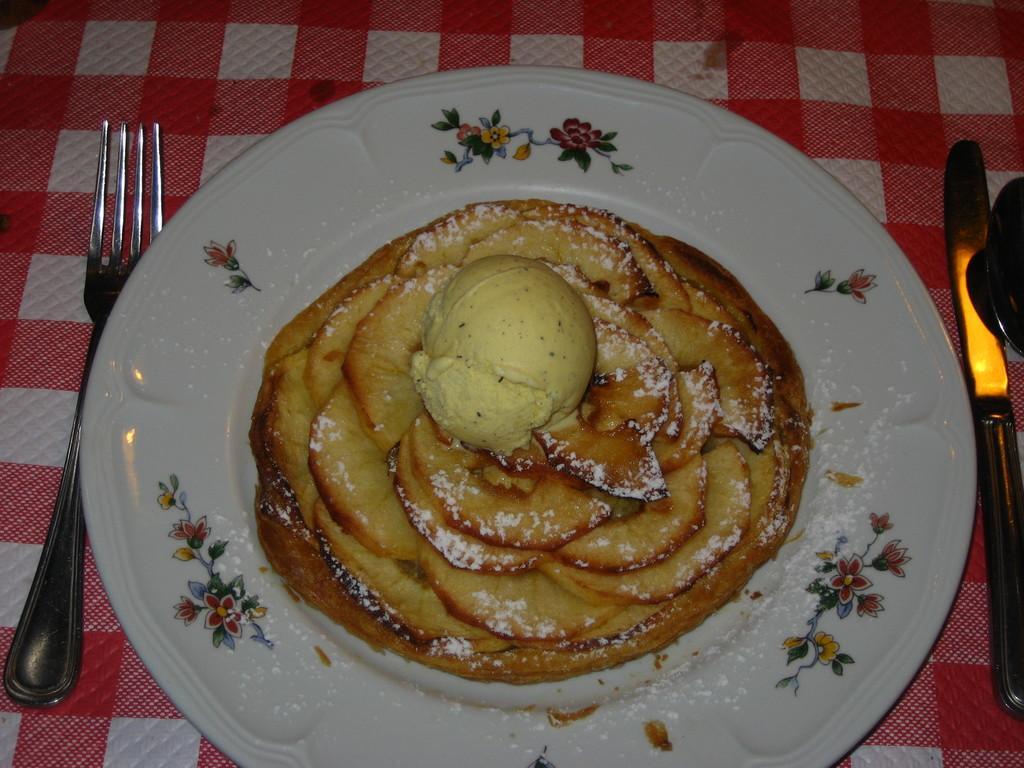Please provide a concise description of this image. There is a plate on a surface. Near to that there is a fork and knife. On the plate there are designs. Also there is a food item. 